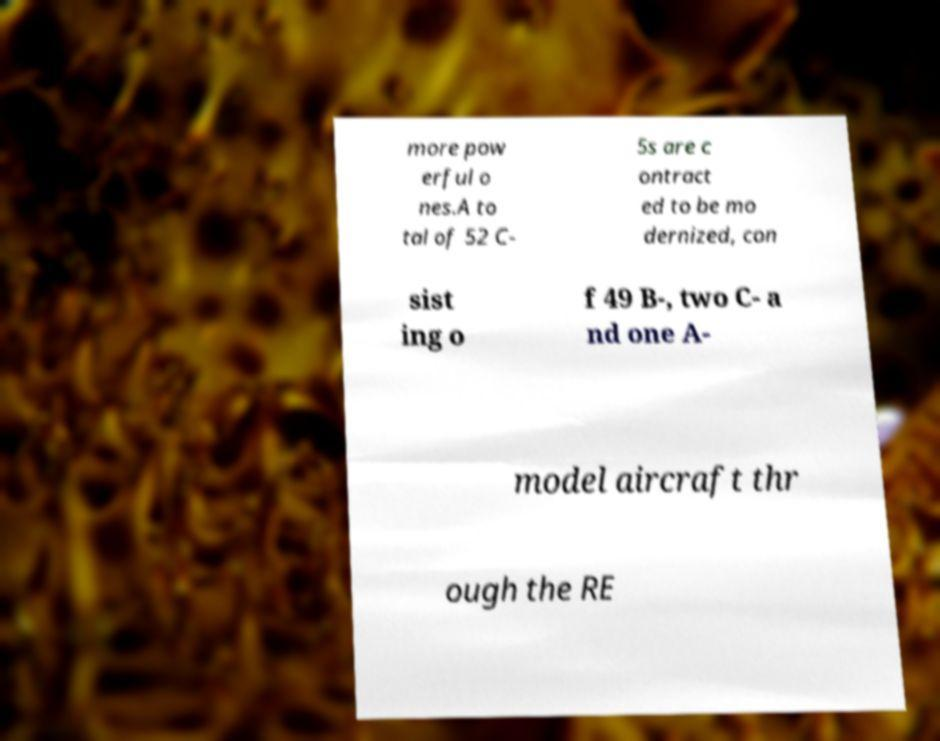Please read and relay the text visible in this image. What does it say? more pow erful o nes.A to tal of 52 C- 5s are c ontract ed to be mo dernized, con sist ing o f 49 B-, two C- a nd one A- model aircraft thr ough the RE 